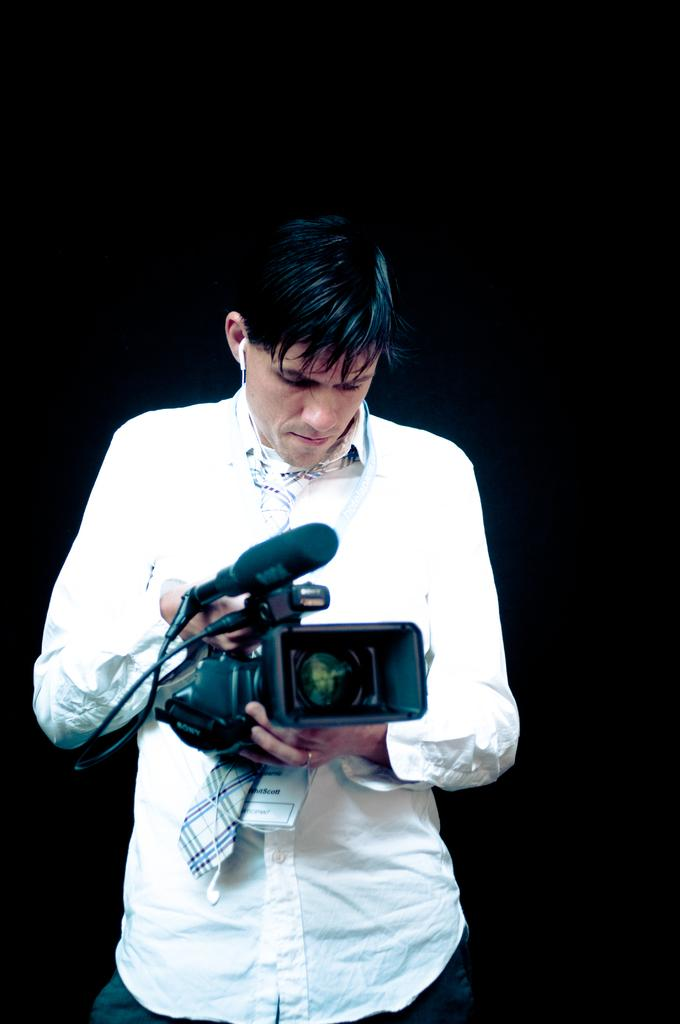What is the main subject of the image? There is a person standing in the image. What is the person holding in the image? The person is holding a camera. What is the person wearing in the image? The person is wearing a white shirt. What is the color of the background in the image? The background of the image is black. What type of soap is being used by the person in the image? There is no soap present in the image, as the person is holding a camera and not engaged in any activity involving soap. 